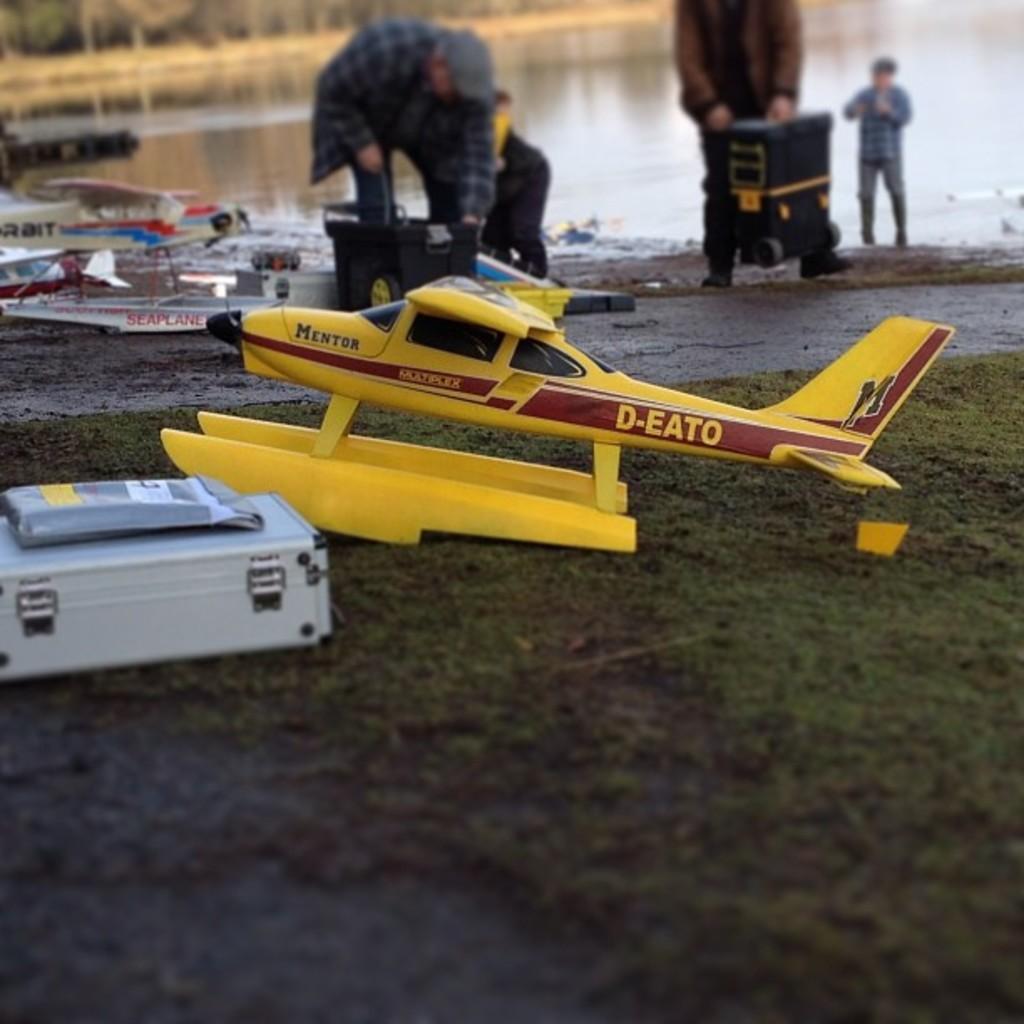Please provide a concise description of this image. In the image there is a toy aircraft, beside that there is some other object and in the background there are few people, they are carrying some items and behind them there is a water surface. 